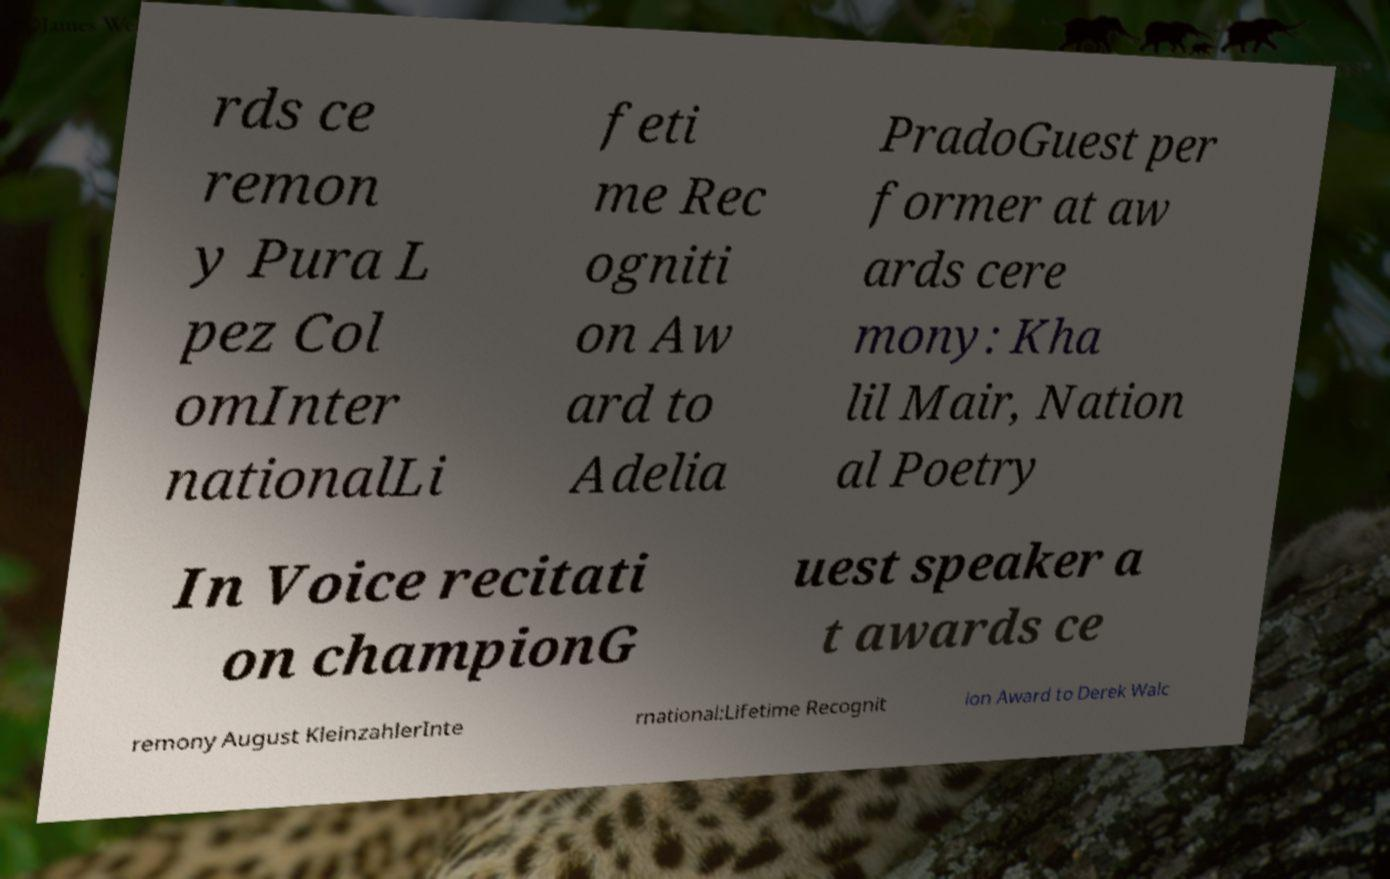Could you extract and type out the text from this image? rds ce remon y Pura L pez Col omInter nationalLi feti me Rec ogniti on Aw ard to Adelia PradoGuest per former at aw ards cere mony: Kha lil Mair, Nation al Poetry In Voice recitati on championG uest speaker a t awards ce remony August KleinzahlerInte rnational:Lifetime Recognit ion Award to Derek Walc 